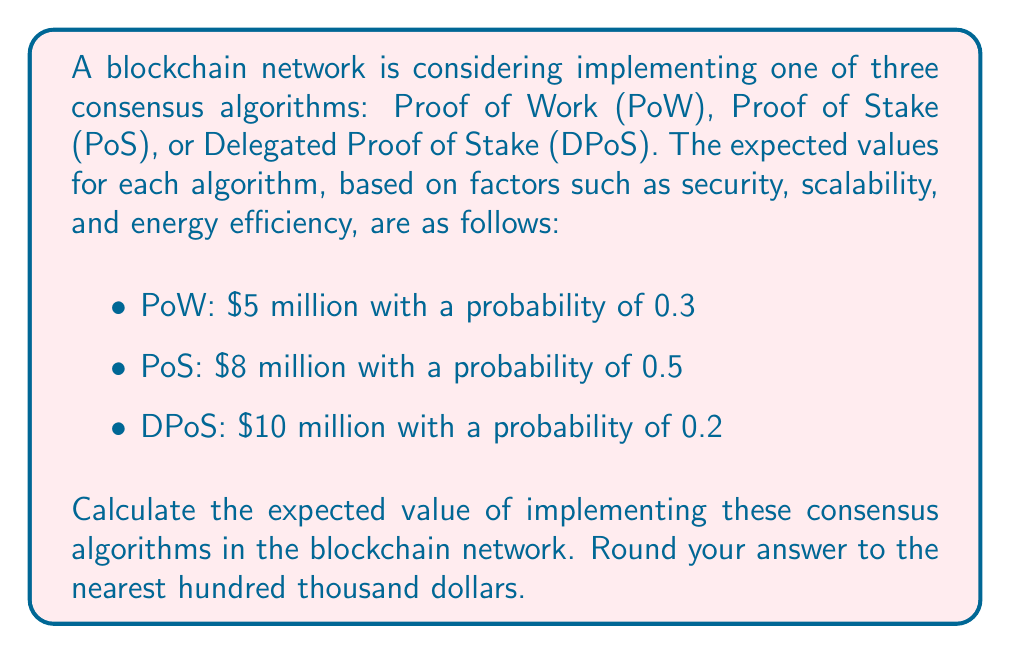Can you answer this question? To solve this problem, we need to use the concept of expected value from decision theory. The expected value is calculated by multiplying each possible outcome by its probability of occurrence and then summing these products.

Let's calculate the expected value for each consensus algorithm:

1. Proof of Work (PoW):
   $EV(PoW) = \$5,000,000 \times 0.3 = \$1,500,000$

2. Proof of Stake (PoS):
   $EV(PoS) = \$8,000,000 \times 0.5 = \$4,000,000$

3. Delegated Proof of Stake (DPoS):
   $EV(DPoS) = \$10,000,000 \times 0.2 = \$2,000,000$

Now, we sum up these individual expected values to get the total expected value:

$$EV(Total) = EV(PoW) + EV(PoS) + EV(DPoS)$$
$$EV(Total) = \$1,500,000 + \$4,000,000 + \$2,000,000 = \$7,500,000$$

Rounding to the nearest hundred thousand dollars:

$$EV(Total) \approx \$7,500,000$$
Answer: $\$7,500,000$ 